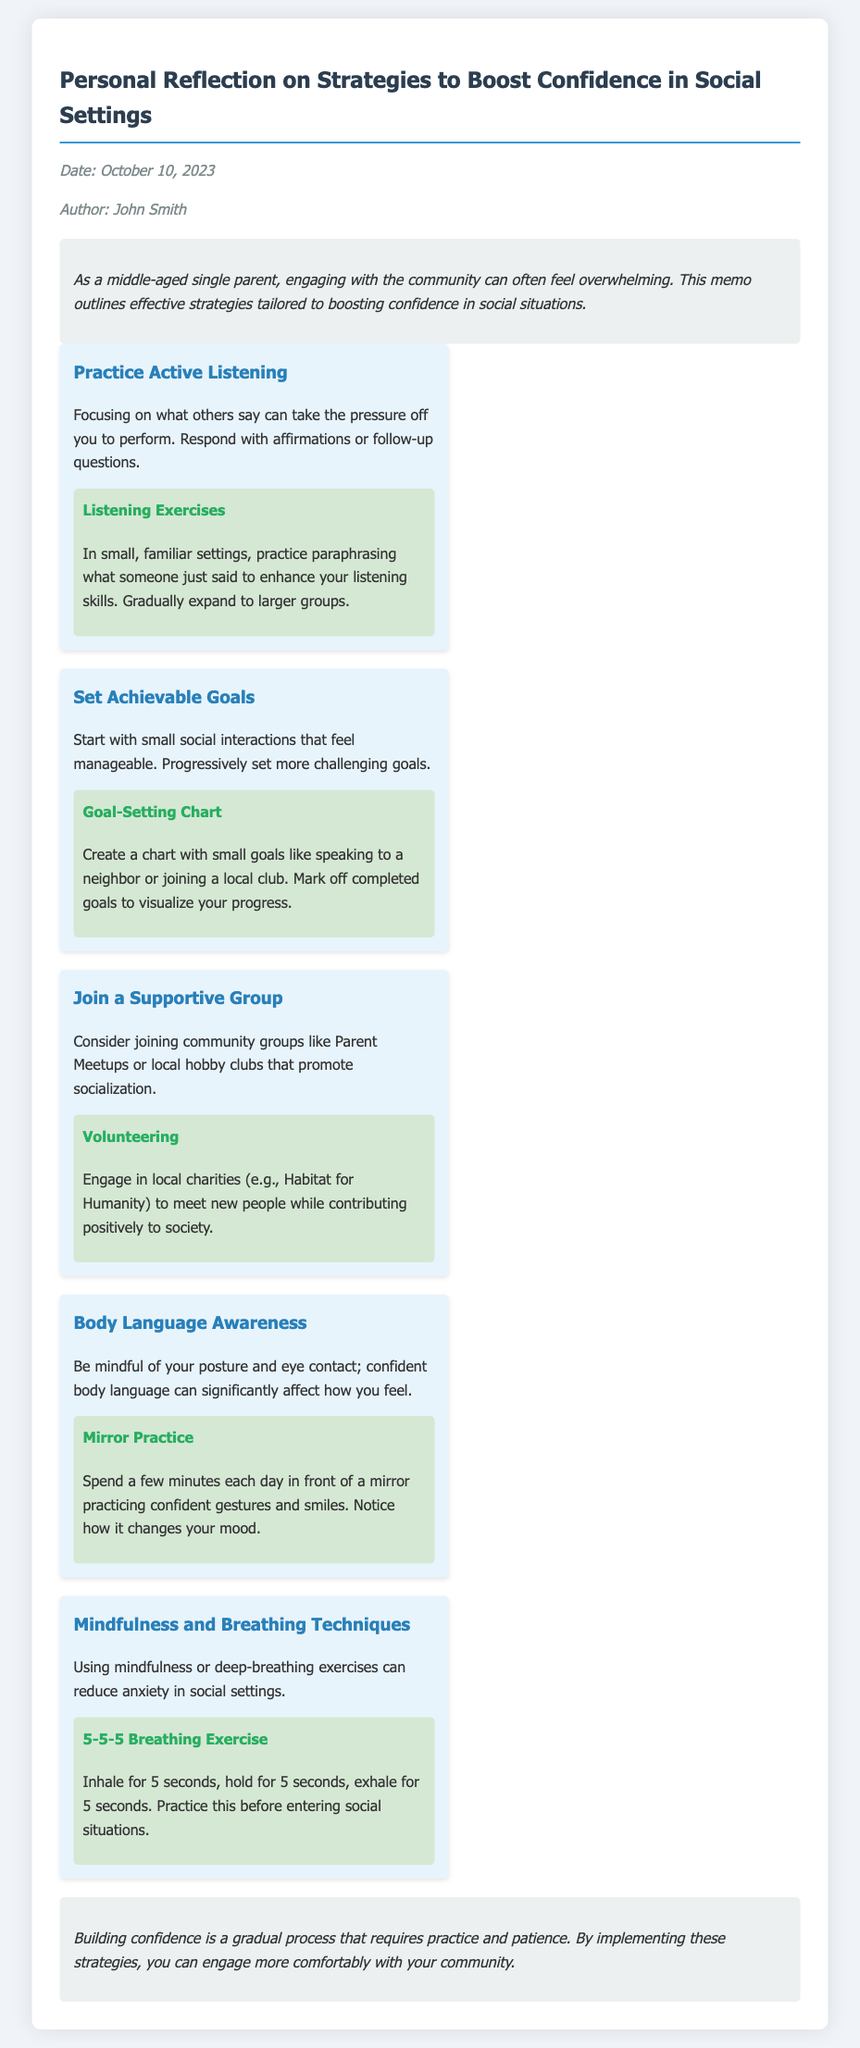what is the title of the memo? The title, found at the top of the document, specifies the main topic discussed.
Answer: Personal Reflection on Strategies to Boost Confidence in Social Settings who is the author of the memo? The author's name is listed in the metadata section of the document.
Answer: John Smith on what date was the memo written? The date is provided in the metadata, indicating when the document was authored.
Answer: October 10, 2023 how many strategies are outlined in the document? The number of strategies is derived from counting the main strategy sections provided.
Answer: Five what is the first strategy mentioned? The first strategy is the primary focus of the initial section on strategies.
Answer: Practice Active Listening what exercise is suggested for improving body language awareness? The specific exercise associated with the body language strategy can be found under that section.
Answer: Mirror Practice what type of groups does the document suggest joining? The type of groups is mentioned in the context of social interaction and support.
Answer: Community groups what breathing technique is recommended in the memo? The breathing technique details the specific method to be practiced to reduce anxiety.
Answer: 5-5-5 Breathing Exercise what is emphasized as a gradual process in the conclusion? The conclusion highlights the nature of a specific skill that requires time to develop.
Answer: Building confidence 